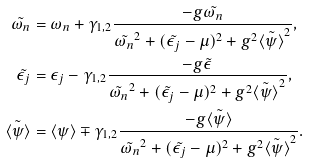Convert formula to latex. <formula><loc_0><loc_0><loc_500><loc_500>\tilde { \omega _ { n } } & = \omega _ { n } + \gamma _ { 1 , 2 } \frac { - g \tilde { \omega _ { n } } } { \tilde { \omega _ { n } } ^ { 2 } + ( \tilde { \epsilon _ { j } } - \mu ) ^ { 2 } + g ^ { 2 } \tilde { \langle \psi \rangle } ^ { 2 } } , \\ \tilde { \epsilon _ { j } } & = \epsilon _ { j } - \gamma _ { 1 , 2 } \frac { - g \tilde { \epsilon } } { \tilde { \omega _ { n } } ^ { 2 } + ( \tilde { \epsilon _ { j } } - \mu ) ^ { 2 } + g ^ { 2 } \tilde { \langle \psi \rangle } ^ { 2 } } , \\ \tilde { \langle \psi \rangle } & = \langle \psi \rangle \mp \gamma _ { 1 , 2 } \frac { - g \tilde { \langle \psi \rangle } } { \tilde { \omega _ { n } } ^ { 2 } + ( \tilde { \epsilon _ { j } } - \mu ) ^ { 2 } + g ^ { 2 } \tilde { \langle \psi \rangle } ^ { 2 } } .</formula> 